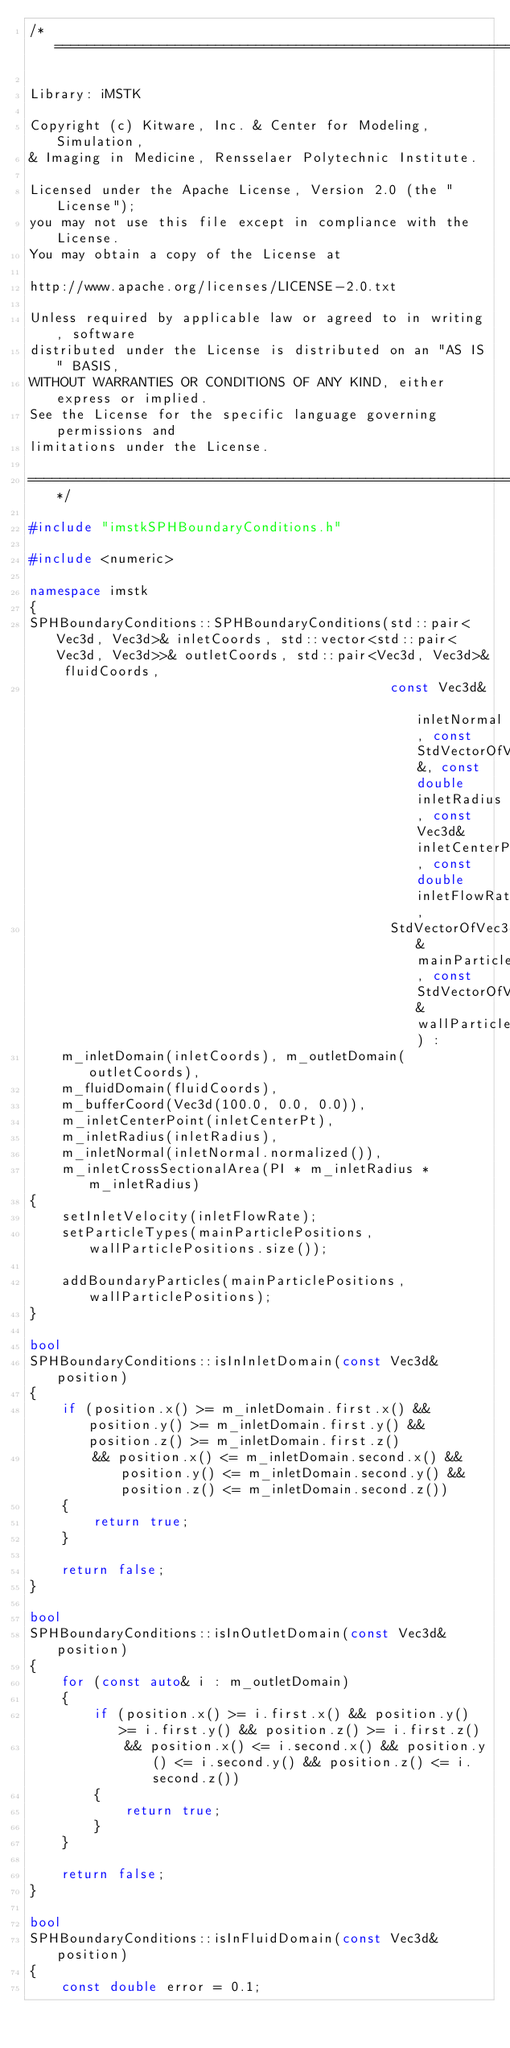<code> <loc_0><loc_0><loc_500><loc_500><_C++_>/*=========================================================================

Library: iMSTK

Copyright (c) Kitware, Inc. & Center for Modeling, Simulation,
& Imaging in Medicine, Rensselaer Polytechnic Institute.

Licensed under the Apache License, Version 2.0 (the "License");
you may not use this file except in compliance with the License.
You may obtain a copy of the License at

http://www.apache.org/licenses/LICENSE-2.0.txt

Unless required by applicable law or agreed to in writing, software
distributed under the License is distributed on an "AS IS" BASIS,
WITHOUT WARRANTIES OR CONDITIONS OF ANY KIND, either express or implied.
See the License for the specific language governing permissions and
limitations under the License.

=========================================================================*/

#include "imstkSPHBoundaryConditions.h"

#include <numeric>

namespace imstk
{
SPHBoundaryConditions::SPHBoundaryConditions(std::pair<Vec3d, Vec3d>& inletCoords, std::vector<std::pair<Vec3d, Vec3d>>& outletCoords, std::pair<Vec3d, Vec3d>& fluidCoords,
                                             const Vec3d& inletNormal, const StdVectorOfVec3d&, const double inletRadius, const Vec3d& inletCenterPt, const double inletFlowRate,
                                             StdVectorOfVec3d& mainParticlePositions, const StdVectorOfVec3d& wallParticlePositions) :
    m_inletDomain(inletCoords), m_outletDomain(outletCoords),
    m_fluidDomain(fluidCoords),
    m_bufferCoord(Vec3d(100.0, 0.0, 0.0)),
    m_inletCenterPoint(inletCenterPt),
    m_inletRadius(inletRadius),
    m_inletNormal(inletNormal.normalized()),
    m_inletCrossSectionalArea(PI * m_inletRadius * m_inletRadius)
{
    setInletVelocity(inletFlowRate);
    setParticleTypes(mainParticlePositions, wallParticlePositions.size());

    addBoundaryParticles(mainParticlePositions, wallParticlePositions);
}

bool
SPHBoundaryConditions::isInInletDomain(const Vec3d& position)
{
    if (position.x() >= m_inletDomain.first.x() && position.y() >= m_inletDomain.first.y() && position.z() >= m_inletDomain.first.z()
        && position.x() <= m_inletDomain.second.x() && position.y() <= m_inletDomain.second.y() && position.z() <= m_inletDomain.second.z())
    {
        return true;
    }

    return false;
}

bool
SPHBoundaryConditions::isInOutletDomain(const Vec3d& position)
{
    for (const auto& i : m_outletDomain)
    {
        if (position.x() >= i.first.x() && position.y() >= i.first.y() && position.z() >= i.first.z()
            && position.x() <= i.second.x() && position.y() <= i.second.y() && position.z() <= i.second.z())
        {
            return true;
        }
    }

    return false;
}

bool
SPHBoundaryConditions::isInFluidDomain(const Vec3d& position)
{
    const double error = 0.1;</code> 